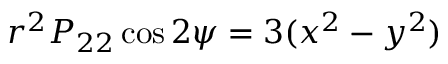<formula> <loc_0><loc_0><loc_500><loc_500>r ^ { 2 } P _ { 2 2 } \cos 2 \psi = 3 ( x ^ { 2 } - y ^ { 2 } )</formula> 